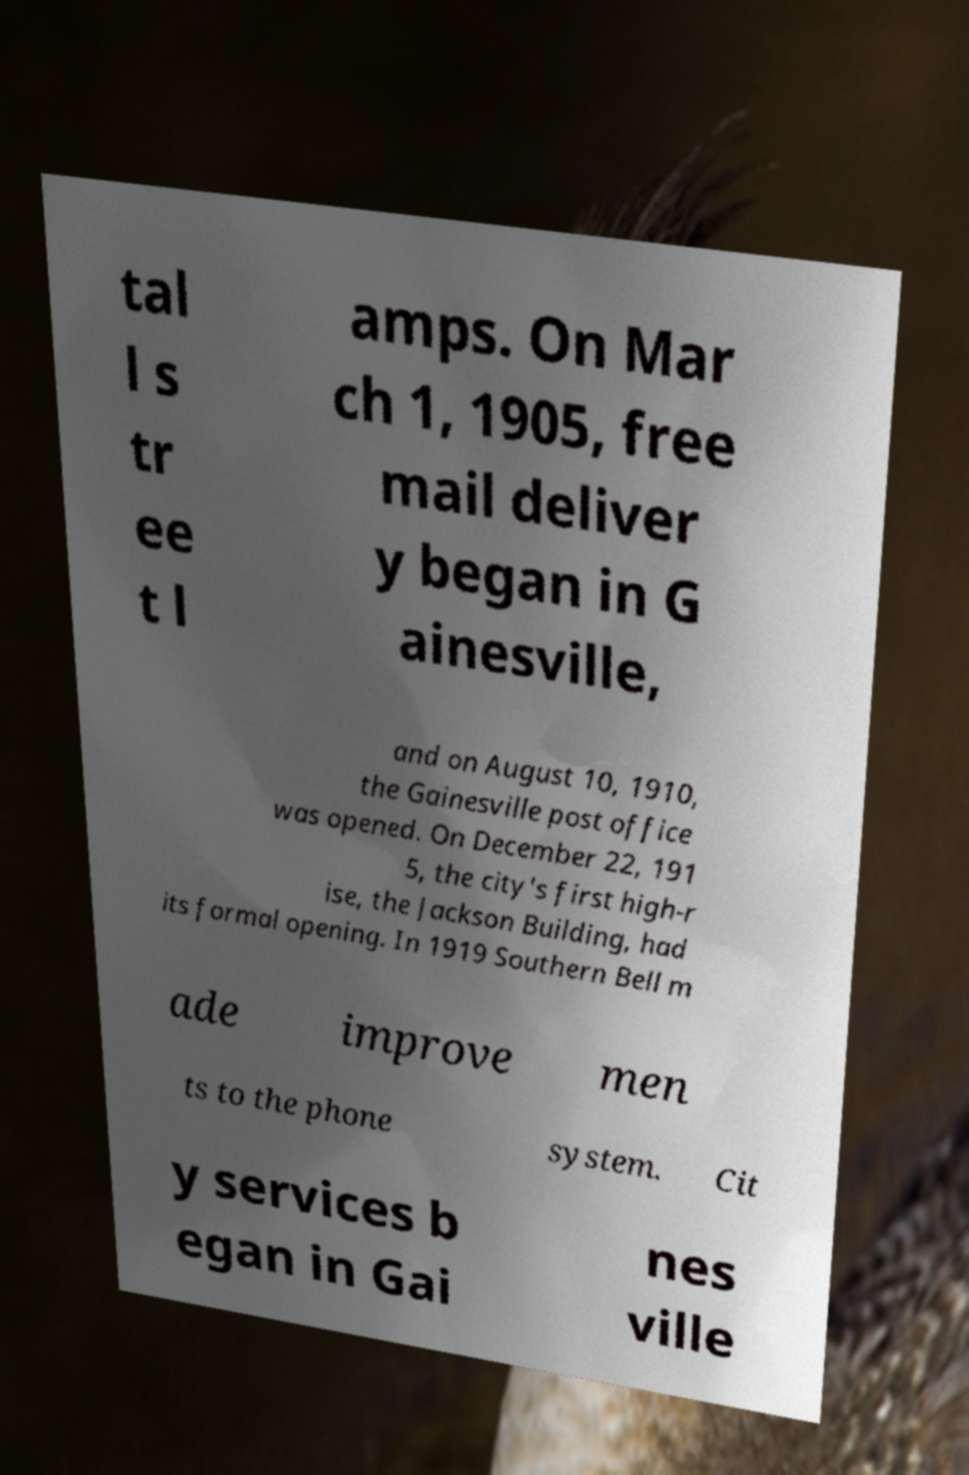For documentation purposes, I need the text within this image transcribed. Could you provide that? tal l s tr ee t l amps. On Mar ch 1, 1905, free mail deliver y began in G ainesville, and on August 10, 1910, the Gainesville post office was opened. On December 22, 191 5, the city's first high-r ise, the Jackson Building, had its formal opening. In 1919 Southern Bell m ade improve men ts to the phone system. Cit y services b egan in Gai nes ville 